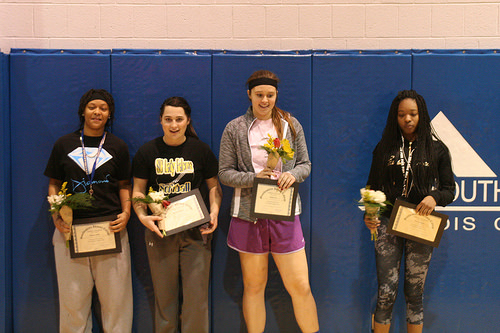<image>
Can you confirm if the headband is on the girl? Yes. Looking at the image, I can see the headband is positioned on top of the girl, with the girl providing support. 